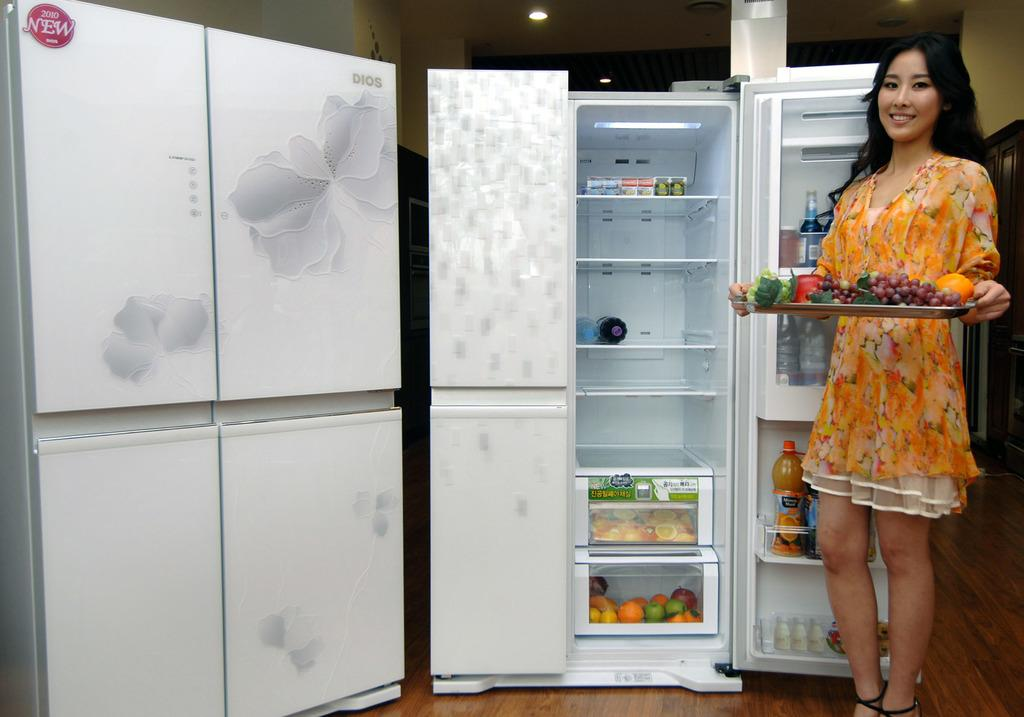<image>
Share a concise interpretation of the image provided. A women holding a tray of fruit in front of a DIOS refrigerator open door. 